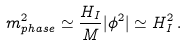<formula> <loc_0><loc_0><loc_500><loc_500>m _ { p h a s e } ^ { 2 } \simeq \frac { H _ { I } } { M } | \phi ^ { 2 } | \simeq H _ { I } ^ { 2 } \, .</formula> 